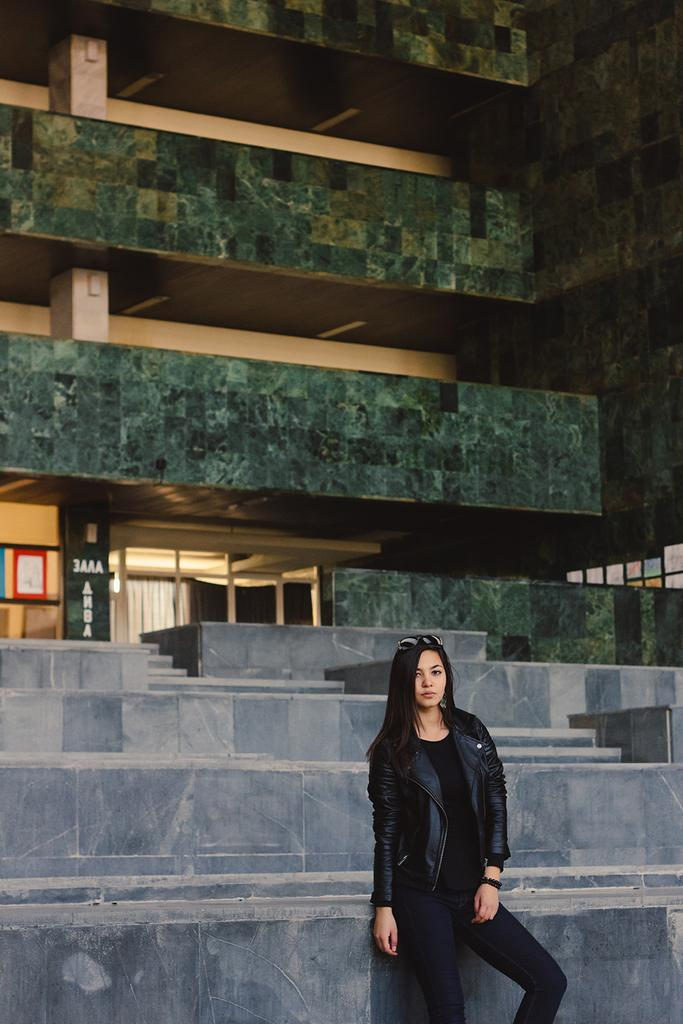What is the main structure in the image? There is a building in the middle of the image. Who or what is located at the bottom of the image? There is a person at the bottom of the image, specifically a woman. What is the woman wearing in the image? The woman is wearing a black dress and a watch. How many ants can be seen crawling on the woman's dress in the image? There are no ants present in the image; the woman is wearing a black dress. What type of fish is swimming near the building in the image? There are no fish present in the image; the main structure is a building. 